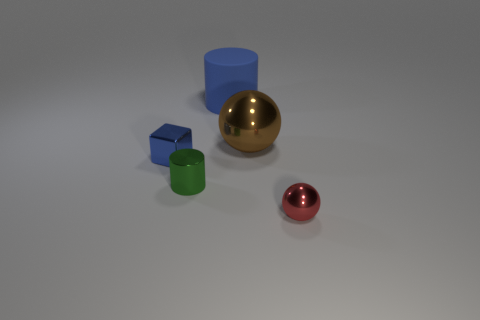Are there any other things that are the same material as the big cylinder?
Offer a very short reply. No. There is a blue thing in front of the cylinder that is behind the tiny blue metal object; is there a tiny object in front of it?
Provide a short and direct response. Yes. What number of tiny objects are metallic cylinders or blue objects?
Ensure brevity in your answer.  2. Are there any other things that are the same color as the tiny metallic cube?
Your response must be concise. Yes. Is the size of the metallic object that is on the left side of the green shiny cylinder the same as the tiny metal ball?
Ensure brevity in your answer.  Yes. What is the color of the cylinder in front of the thing behind the metallic ball left of the tiny red shiny thing?
Offer a terse response. Green. What is the color of the small ball?
Offer a terse response. Red. Does the big rubber thing have the same color as the tiny shiny block?
Offer a terse response. Yes. Is the cylinder in front of the blue metal block made of the same material as the ball that is behind the small blue metallic object?
Make the answer very short. Yes. There is another large object that is the same shape as the green shiny object; what material is it?
Give a very brief answer. Rubber. 